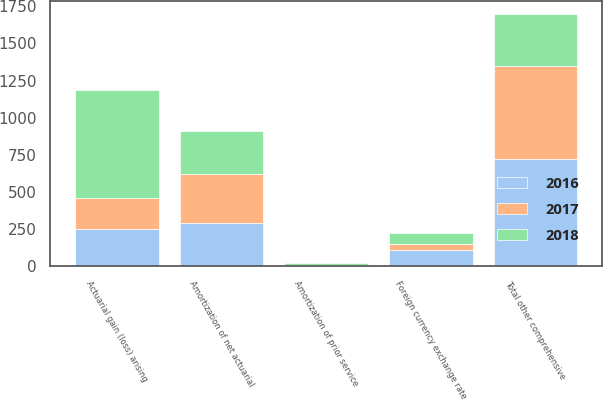Convert chart. <chart><loc_0><loc_0><loc_500><loc_500><stacked_bar_chart><ecel><fcel>Actuarial gain (loss) arising<fcel>Amortization of prior service<fcel>Amortization of net actuarial<fcel>Foreign currency exchange rate<fcel>Total other comprehensive<nl><fcel>2017<fcel>211.1<fcel>4.8<fcel>334.4<fcel>45.2<fcel>623.1<nl><fcel>2016<fcel>248.35<fcel>5.7<fcel>288.2<fcel>105.3<fcel>723.3<nl><fcel>2018<fcel>725.2<fcel>11.8<fcel>285.6<fcel>75.6<fcel>352.2<nl></chart> 